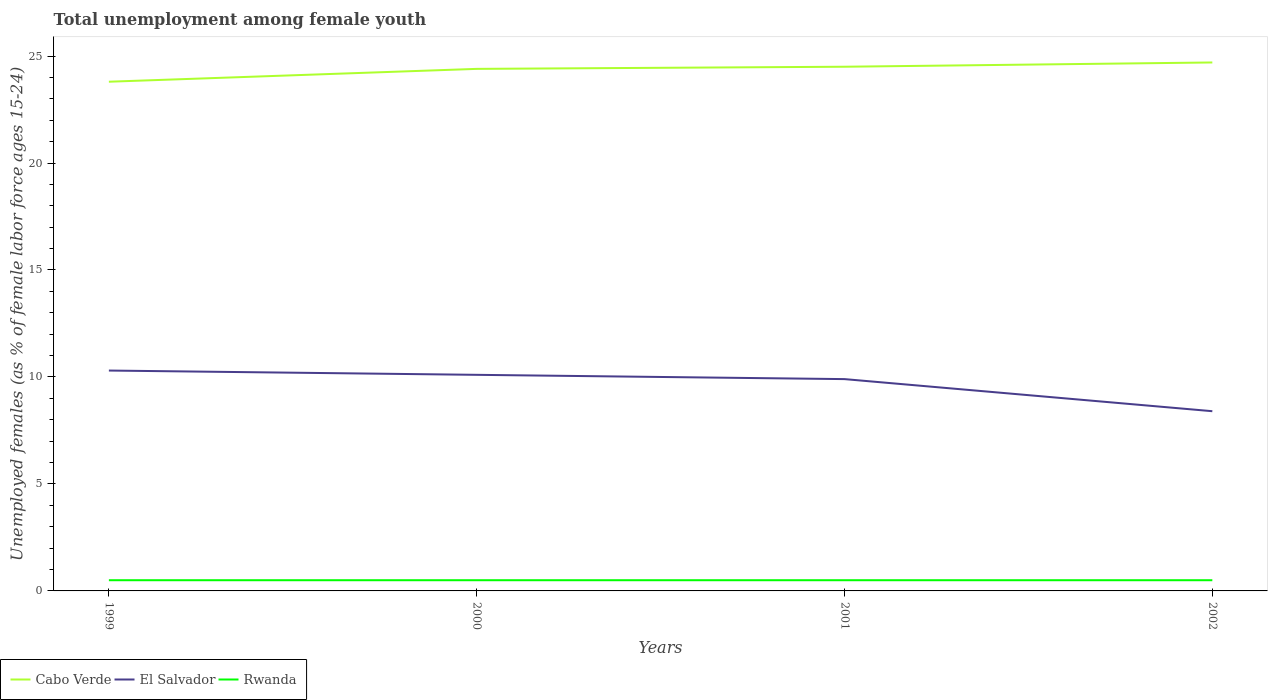How many different coloured lines are there?
Keep it short and to the point. 3. Does the line corresponding to Rwanda intersect with the line corresponding to Cabo Verde?
Provide a short and direct response. No. Across all years, what is the maximum percentage of unemployed females in in Cabo Verde?
Provide a short and direct response. 23.8. In which year was the percentage of unemployed females in in Rwanda maximum?
Your answer should be compact. 1999. What is the total percentage of unemployed females in in Cabo Verde in the graph?
Your answer should be compact. -0.9. What is the difference between the highest and the second highest percentage of unemployed females in in Cabo Verde?
Your response must be concise. 0.9. What is the difference between the highest and the lowest percentage of unemployed females in in Cabo Verde?
Keep it short and to the point. 3. Is the percentage of unemployed females in in El Salvador strictly greater than the percentage of unemployed females in in Cabo Verde over the years?
Make the answer very short. Yes. How many lines are there?
Offer a very short reply. 3. Are the values on the major ticks of Y-axis written in scientific E-notation?
Make the answer very short. No. Does the graph contain any zero values?
Provide a short and direct response. No. What is the title of the graph?
Ensure brevity in your answer.  Total unemployment among female youth. What is the label or title of the Y-axis?
Your response must be concise. Unemployed females (as % of female labor force ages 15-24). What is the Unemployed females (as % of female labor force ages 15-24) in Cabo Verde in 1999?
Provide a short and direct response. 23.8. What is the Unemployed females (as % of female labor force ages 15-24) of El Salvador in 1999?
Ensure brevity in your answer.  10.3. What is the Unemployed females (as % of female labor force ages 15-24) in Cabo Verde in 2000?
Your answer should be very brief. 24.4. What is the Unemployed females (as % of female labor force ages 15-24) in El Salvador in 2000?
Offer a very short reply. 10.1. What is the Unemployed females (as % of female labor force ages 15-24) in Cabo Verde in 2001?
Your response must be concise. 24.5. What is the Unemployed females (as % of female labor force ages 15-24) in El Salvador in 2001?
Offer a terse response. 9.9. What is the Unemployed females (as % of female labor force ages 15-24) in Cabo Verde in 2002?
Your response must be concise. 24.7. What is the Unemployed females (as % of female labor force ages 15-24) in El Salvador in 2002?
Your response must be concise. 8.4. Across all years, what is the maximum Unemployed females (as % of female labor force ages 15-24) in Cabo Verde?
Offer a very short reply. 24.7. Across all years, what is the maximum Unemployed females (as % of female labor force ages 15-24) of El Salvador?
Provide a short and direct response. 10.3. Across all years, what is the maximum Unemployed females (as % of female labor force ages 15-24) of Rwanda?
Give a very brief answer. 0.5. Across all years, what is the minimum Unemployed females (as % of female labor force ages 15-24) in Cabo Verde?
Offer a very short reply. 23.8. Across all years, what is the minimum Unemployed females (as % of female labor force ages 15-24) of El Salvador?
Your answer should be compact. 8.4. Across all years, what is the minimum Unemployed females (as % of female labor force ages 15-24) of Rwanda?
Offer a very short reply. 0.5. What is the total Unemployed females (as % of female labor force ages 15-24) of Cabo Verde in the graph?
Provide a succinct answer. 97.4. What is the total Unemployed females (as % of female labor force ages 15-24) of El Salvador in the graph?
Provide a short and direct response. 38.7. What is the difference between the Unemployed females (as % of female labor force ages 15-24) in Rwanda in 1999 and that in 2000?
Your response must be concise. 0. What is the difference between the Unemployed females (as % of female labor force ages 15-24) of Cabo Verde in 1999 and that in 2001?
Your answer should be very brief. -0.7. What is the difference between the Unemployed females (as % of female labor force ages 15-24) of El Salvador in 1999 and that in 2001?
Provide a succinct answer. 0.4. What is the difference between the Unemployed females (as % of female labor force ages 15-24) of Rwanda in 1999 and that in 2002?
Keep it short and to the point. 0. What is the difference between the Unemployed females (as % of female labor force ages 15-24) in Cabo Verde in 2000 and that in 2001?
Keep it short and to the point. -0.1. What is the difference between the Unemployed females (as % of female labor force ages 15-24) in Rwanda in 2000 and that in 2001?
Your answer should be very brief. 0. What is the difference between the Unemployed females (as % of female labor force ages 15-24) in El Salvador in 2000 and that in 2002?
Offer a terse response. 1.7. What is the difference between the Unemployed females (as % of female labor force ages 15-24) in Cabo Verde in 2001 and that in 2002?
Give a very brief answer. -0.2. What is the difference between the Unemployed females (as % of female labor force ages 15-24) of El Salvador in 2001 and that in 2002?
Your answer should be very brief. 1.5. What is the difference between the Unemployed females (as % of female labor force ages 15-24) in Rwanda in 2001 and that in 2002?
Give a very brief answer. 0. What is the difference between the Unemployed females (as % of female labor force ages 15-24) of Cabo Verde in 1999 and the Unemployed females (as % of female labor force ages 15-24) of El Salvador in 2000?
Make the answer very short. 13.7. What is the difference between the Unemployed females (as % of female labor force ages 15-24) of Cabo Verde in 1999 and the Unemployed females (as % of female labor force ages 15-24) of Rwanda in 2000?
Provide a short and direct response. 23.3. What is the difference between the Unemployed females (as % of female labor force ages 15-24) of Cabo Verde in 1999 and the Unemployed females (as % of female labor force ages 15-24) of Rwanda in 2001?
Your answer should be very brief. 23.3. What is the difference between the Unemployed females (as % of female labor force ages 15-24) in El Salvador in 1999 and the Unemployed females (as % of female labor force ages 15-24) in Rwanda in 2001?
Your answer should be compact. 9.8. What is the difference between the Unemployed females (as % of female labor force ages 15-24) in Cabo Verde in 1999 and the Unemployed females (as % of female labor force ages 15-24) in El Salvador in 2002?
Offer a terse response. 15.4. What is the difference between the Unemployed females (as % of female labor force ages 15-24) in Cabo Verde in 1999 and the Unemployed females (as % of female labor force ages 15-24) in Rwanda in 2002?
Provide a succinct answer. 23.3. What is the difference between the Unemployed females (as % of female labor force ages 15-24) in El Salvador in 1999 and the Unemployed females (as % of female labor force ages 15-24) in Rwanda in 2002?
Offer a terse response. 9.8. What is the difference between the Unemployed females (as % of female labor force ages 15-24) in Cabo Verde in 2000 and the Unemployed females (as % of female labor force ages 15-24) in El Salvador in 2001?
Offer a very short reply. 14.5. What is the difference between the Unemployed females (as % of female labor force ages 15-24) of Cabo Verde in 2000 and the Unemployed females (as % of female labor force ages 15-24) of Rwanda in 2001?
Ensure brevity in your answer.  23.9. What is the difference between the Unemployed females (as % of female labor force ages 15-24) of El Salvador in 2000 and the Unemployed females (as % of female labor force ages 15-24) of Rwanda in 2001?
Give a very brief answer. 9.6. What is the difference between the Unemployed females (as % of female labor force ages 15-24) in Cabo Verde in 2000 and the Unemployed females (as % of female labor force ages 15-24) in El Salvador in 2002?
Your answer should be compact. 16. What is the difference between the Unemployed females (as % of female labor force ages 15-24) of Cabo Verde in 2000 and the Unemployed females (as % of female labor force ages 15-24) of Rwanda in 2002?
Your answer should be very brief. 23.9. What is the difference between the Unemployed females (as % of female labor force ages 15-24) in El Salvador in 2000 and the Unemployed females (as % of female labor force ages 15-24) in Rwanda in 2002?
Provide a short and direct response. 9.6. What is the difference between the Unemployed females (as % of female labor force ages 15-24) of Cabo Verde in 2001 and the Unemployed females (as % of female labor force ages 15-24) of Rwanda in 2002?
Offer a very short reply. 24. What is the average Unemployed females (as % of female labor force ages 15-24) in Cabo Verde per year?
Ensure brevity in your answer.  24.35. What is the average Unemployed females (as % of female labor force ages 15-24) of El Salvador per year?
Make the answer very short. 9.68. In the year 1999, what is the difference between the Unemployed females (as % of female labor force ages 15-24) of Cabo Verde and Unemployed females (as % of female labor force ages 15-24) of El Salvador?
Make the answer very short. 13.5. In the year 1999, what is the difference between the Unemployed females (as % of female labor force ages 15-24) in Cabo Verde and Unemployed females (as % of female labor force ages 15-24) in Rwanda?
Provide a short and direct response. 23.3. In the year 1999, what is the difference between the Unemployed females (as % of female labor force ages 15-24) in El Salvador and Unemployed females (as % of female labor force ages 15-24) in Rwanda?
Your response must be concise. 9.8. In the year 2000, what is the difference between the Unemployed females (as % of female labor force ages 15-24) in Cabo Verde and Unemployed females (as % of female labor force ages 15-24) in El Salvador?
Make the answer very short. 14.3. In the year 2000, what is the difference between the Unemployed females (as % of female labor force ages 15-24) in Cabo Verde and Unemployed females (as % of female labor force ages 15-24) in Rwanda?
Your answer should be very brief. 23.9. In the year 2000, what is the difference between the Unemployed females (as % of female labor force ages 15-24) in El Salvador and Unemployed females (as % of female labor force ages 15-24) in Rwanda?
Offer a terse response. 9.6. In the year 2002, what is the difference between the Unemployed females (as % of female labor force ages 15-24) in Cabo Verde and Unemployed females (as % of female labor force ages 15-24) in El Salvador?
Offer a very short reply. 16.3. In the year 2002, what is the difference between the Unemployed females (as % of female labor force ages 15-24) in Cabo Verde and Unemployed females (as % of female labor force ages 15-24) in Rwanda?
Your answer should be very brief. 24.2. What is the ratio of the Unemployed females (as % of female labor force ages 15-24) of Cabo Verde in 1999 to that in 2000?
Provide a short and direct response. 0.98. What is the ratio of the Unemployed females (as % of female labor force ages 15-24) in El Salvador in 1999 to that in 2000?
Your answer should be compact. 1.02. What is the ratio of the Unemployed females (as % of female labor force ages 15-24) in Rwanda in 1999 to that in 2000?
Provide a short and direct response. 1. What is the ratio of the Unemployed females (as % of female labor force ages 15-24) of Cabo Verde in 1999 to that in 2001?
Provide a succinct answer. 0.97. What is the ratio of the Unemployed females (as % of female labor force ages 15-24) in El Salvador in 1999 to that in 2001?
Your response must be concise. 1.04. What is the ratio of the Unemployed females (as % of female labor force ages 15-24) of Rwanda in 1999 to that in 2001?
Your response must be concise. 1. What is the ratio of the Unemployed females (as % of female labor force ages 15-24) in Cabo Verde in 1999 to that in 2002?
Your answer should be compact. 0.96. What is the ratio of the Unemployed females (as % of female labor force ages 15-24) of El Salvador in 1999 to that in 2002?
Make the answer very short. 1.23. What is the ratio of the Unemployed females (as % of female labor force ages 15-24) of Rwanda in 1999 to that in 2002?
Offer a terse response. 1. What is the ratio of the Unemployed females (as % of female labor force ages 15-24) in Cabo Verde in 2000 to that in 2001?
Make the answer very short. 1. What is the ratio of the Unemployed females (as % of female labor force ages 15-24) of El Salvador in 2000 to that in 2001?
Ensure brevity in your answer.  1.02. What is the ratio of the Unemployed females (as % of female labor force ages 15-24) of Rwanda in 2000 to that in 2001?
Offer a terse response. 1. What is the ratio of the Unemployed females (as % of female labor force ages 15-24) of Cabo Verde in 2000 to that in 2002?
Provide a succinct answer. 0.99. What is the ratio of the Unemployed females (as % of female labor force ages 15-24) in El Salvador in 2000 to that in 2002?
Provide a succinct answer. 1.2. What is the ratio of the Unemployed females (as % of female labor force ages 15-24) in Cabo Verde in 2001 to that in 2002?
Keep it short and to the point. 0.99. What is the ratio of the Unemployed females (as % of female labor force ages 15-24) of El Salvador in 2001 to that in 2002?
Give a very brief answer. 1.18. What is the ratio of the Unemployed females (as % of female labor force ages 15-24) of Rwanda in 2001 to that in 2002?
Make the answer very short. 1. What is the difference between the highest and the second highest Unemployed females (as % of female labor force ages 15-24) of Rwanda?
Provide a short and direct response. 0. What is the difference between the highest and the lowest Unemployed females (as % of female labor force ages 15-24) in Cabo Verde?
Provide a succinct answer. 0.9. What is the difference between the highest and the lowest Unemployed females (as % of female labor force ages 15-24) of Rwanda?
Give a very brief answer. 0. 